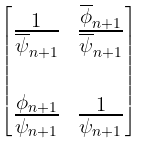Convert formula to latex. <formula><loc_0><loc_0><loc_500><loc_500>\begin{bmatrix} \frac { 1 } { \overline { \psi } _ { n + 1 } } & \frac { \overline { \phi } _ { n + 1 } } { \overline { \psi } _ { n + 1 } } \\ \\ \frac { \phi _ { n + 1 } } { \psi _ { n + 1 } } & \frac { 1 } { \psi _ { n + 1 } } \end{bmatrix}</formula> 